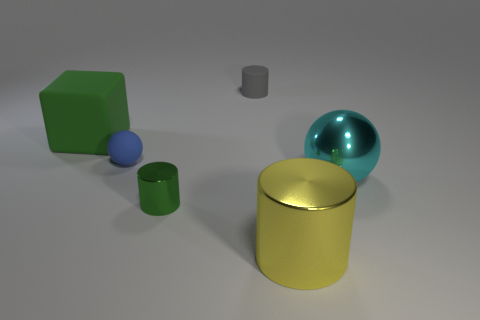Add 4 big cyan metal balls. How many objects exist? 10 Subtract all blocks. How many objects are left? 5 Subtract all cyan spheres. Subtract all gray matte cylinders. How many objects are left? 4 Add 3 blue matte balls. How many blue matte balls are left? 4 Add 4 big yellow objects. How many big yellow objects exist? 5 Subtract 0 red balls. How many objects are left? 6 